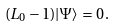<formula> <loc_0><loc_0><loc_500><loc_500>( L _ { 0 } - 1 ) | \Psi \rangle = 0 \, .</formula> 